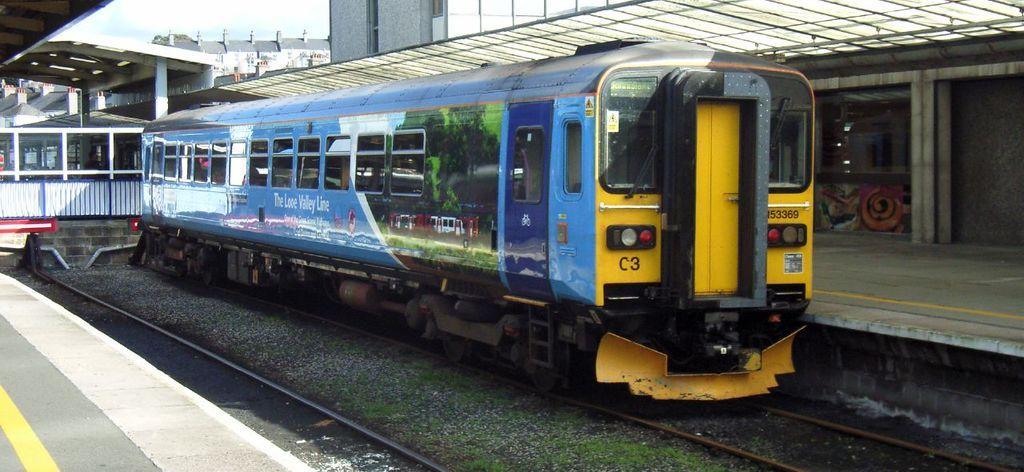Could you give a brief overview of what you see in this image? In this picture we can see a small train on the railway track with a sheltered platform on either side. 